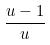Convert formula to latex. <formula><loc_0><loc_0><loc_500><loc_500>\frac { u - 1 } { u }</formula> 